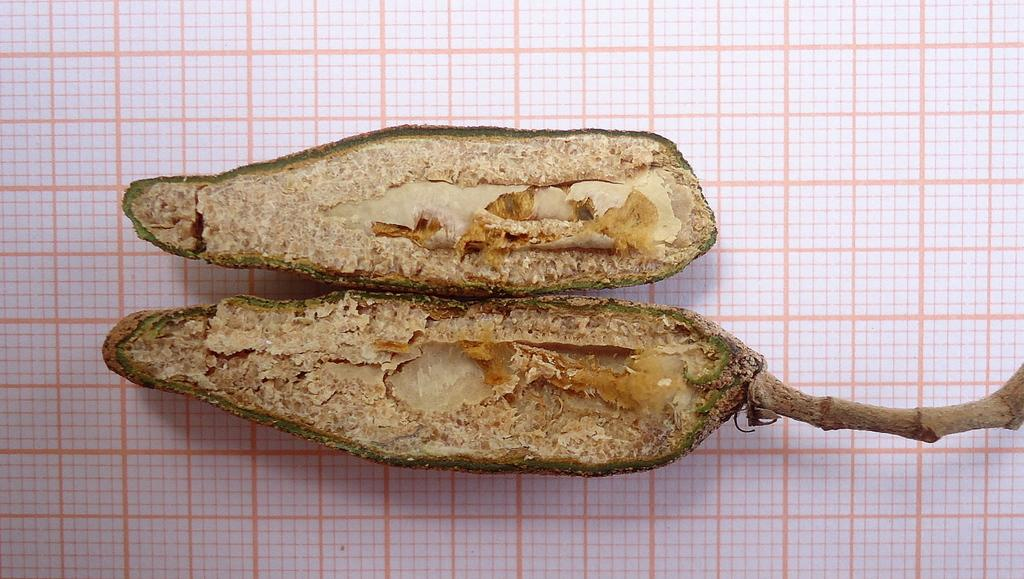What type of food can be seen in the image? There are fruits in the image. Where are the fruits placed in the image? The fruits are kept on a surface. Can you see any cords in the image? There are no cords visible in the image. What type of ocean can be seen in the image? There is no ocean present in the image; it features fruits on a surface. 